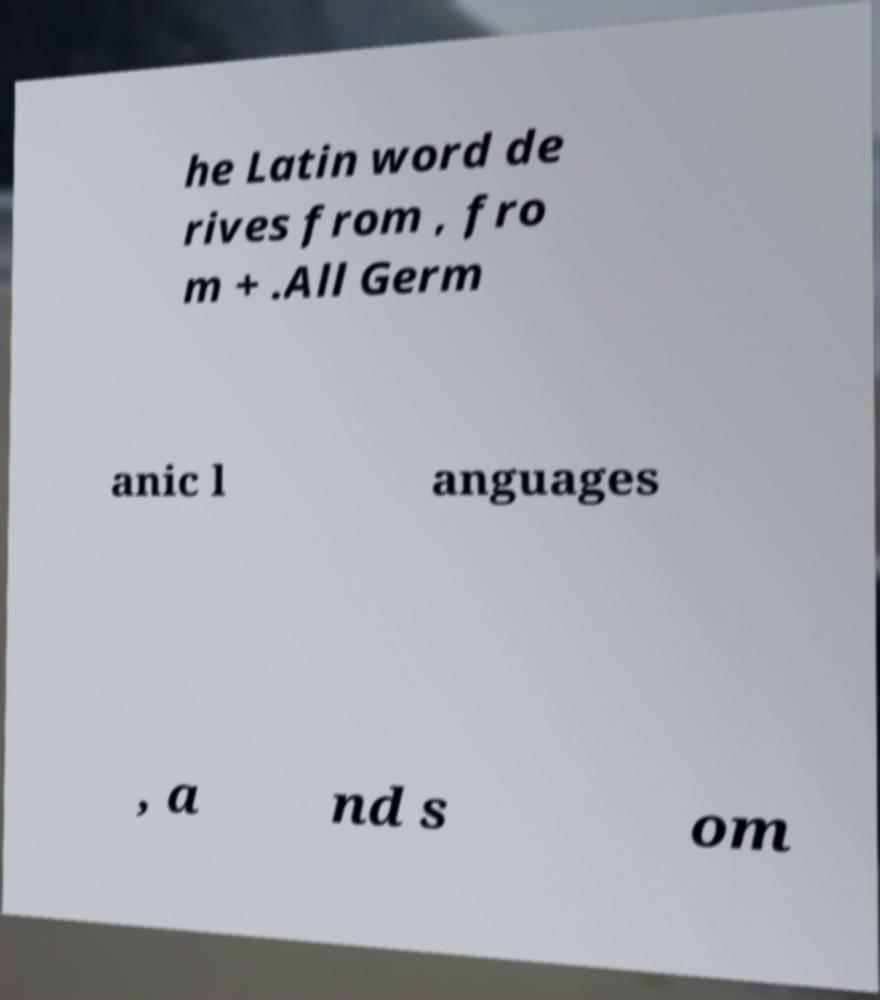Please identify and transcribe the text found in this image. he Latin word de rives from , fro m + .All Germ anic l anguages , a nd s om 